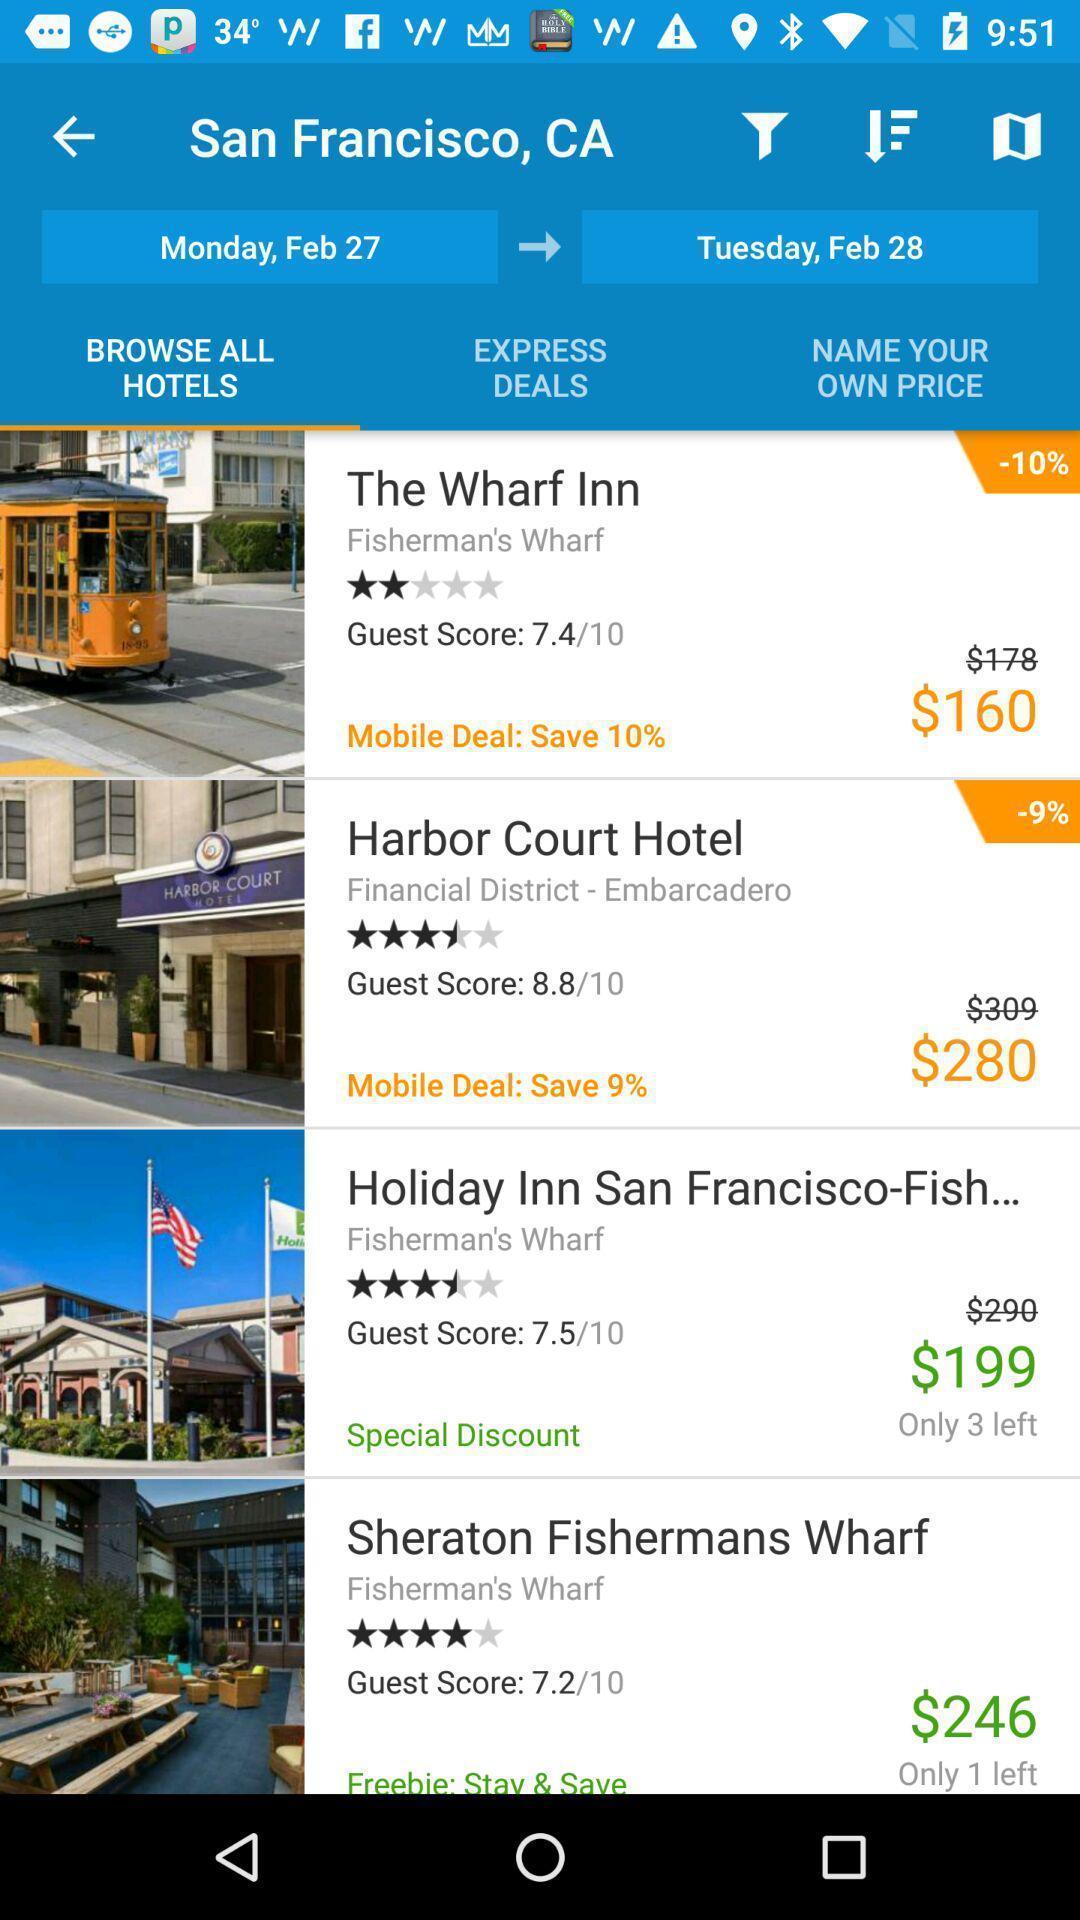Explain the elements present in this screenshot. Screen displaying a list of hotels in a location. 